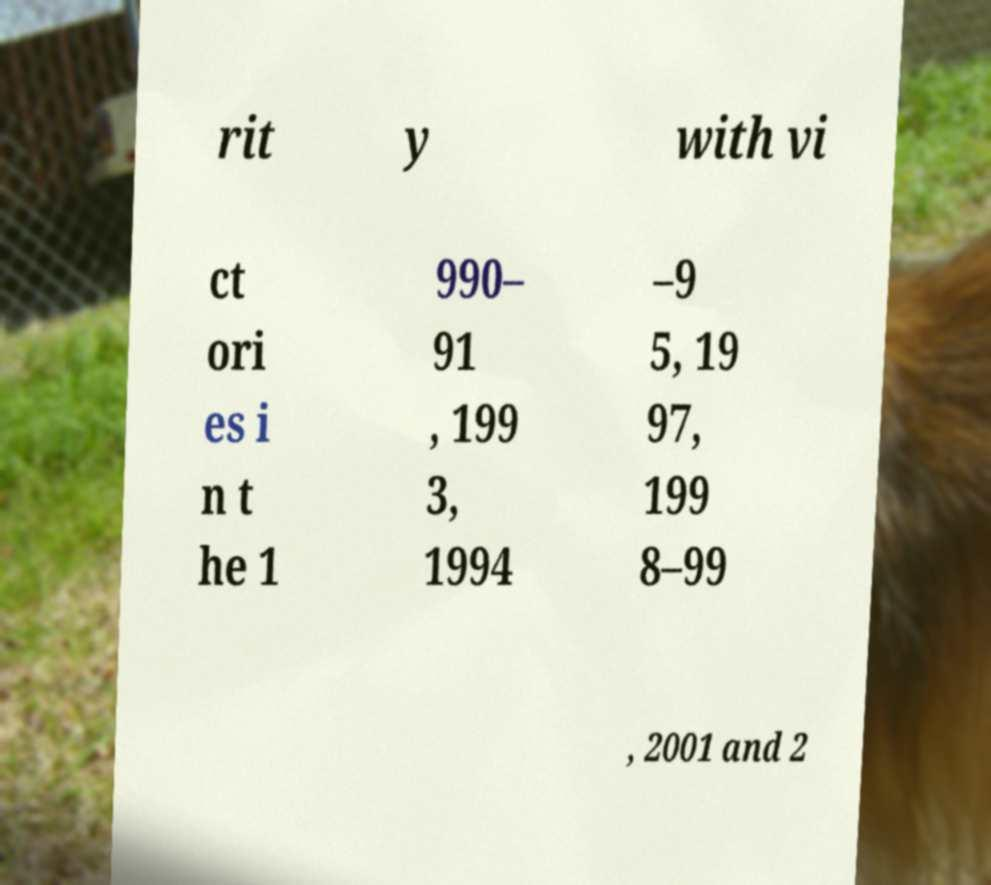Can you accurately transcribe the text from the provided image for me? rit y with vi ct ori es i n t he 1 990– 91 , 199 3, 1994 –9 5, 19 97, 199 8–99 , 2001 and 2 